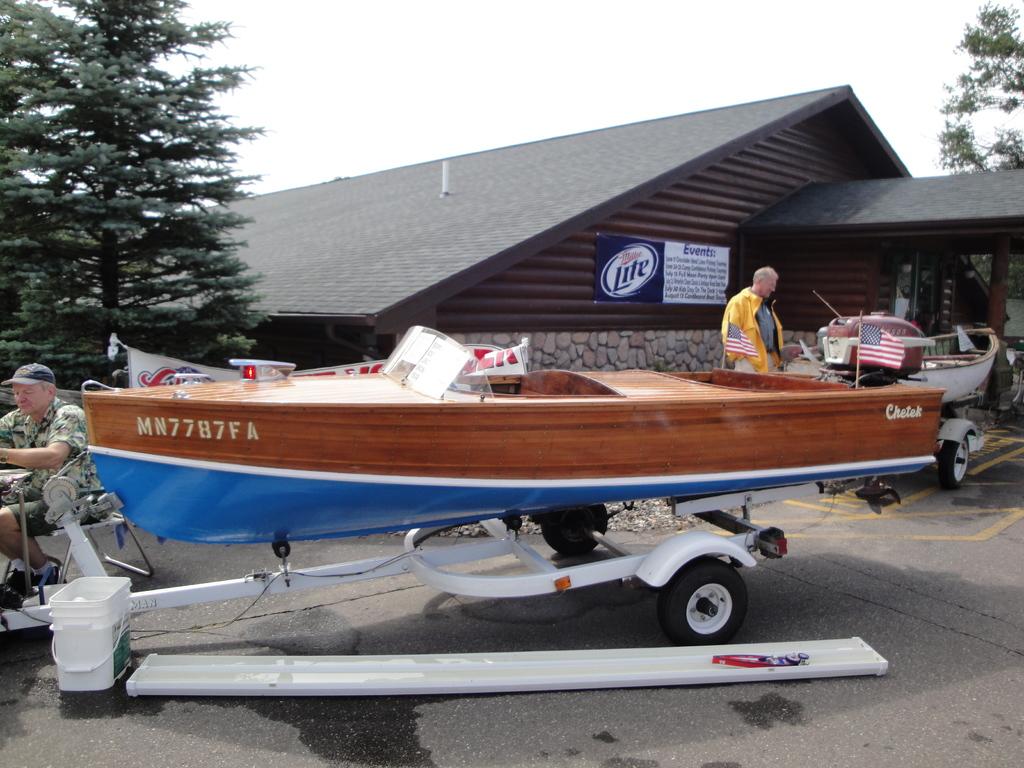What is this boats number?
Give a very brief answer. Mn7787fa. Is that a miller lite banner in the back?
Provide a succinct answer. Yes. 